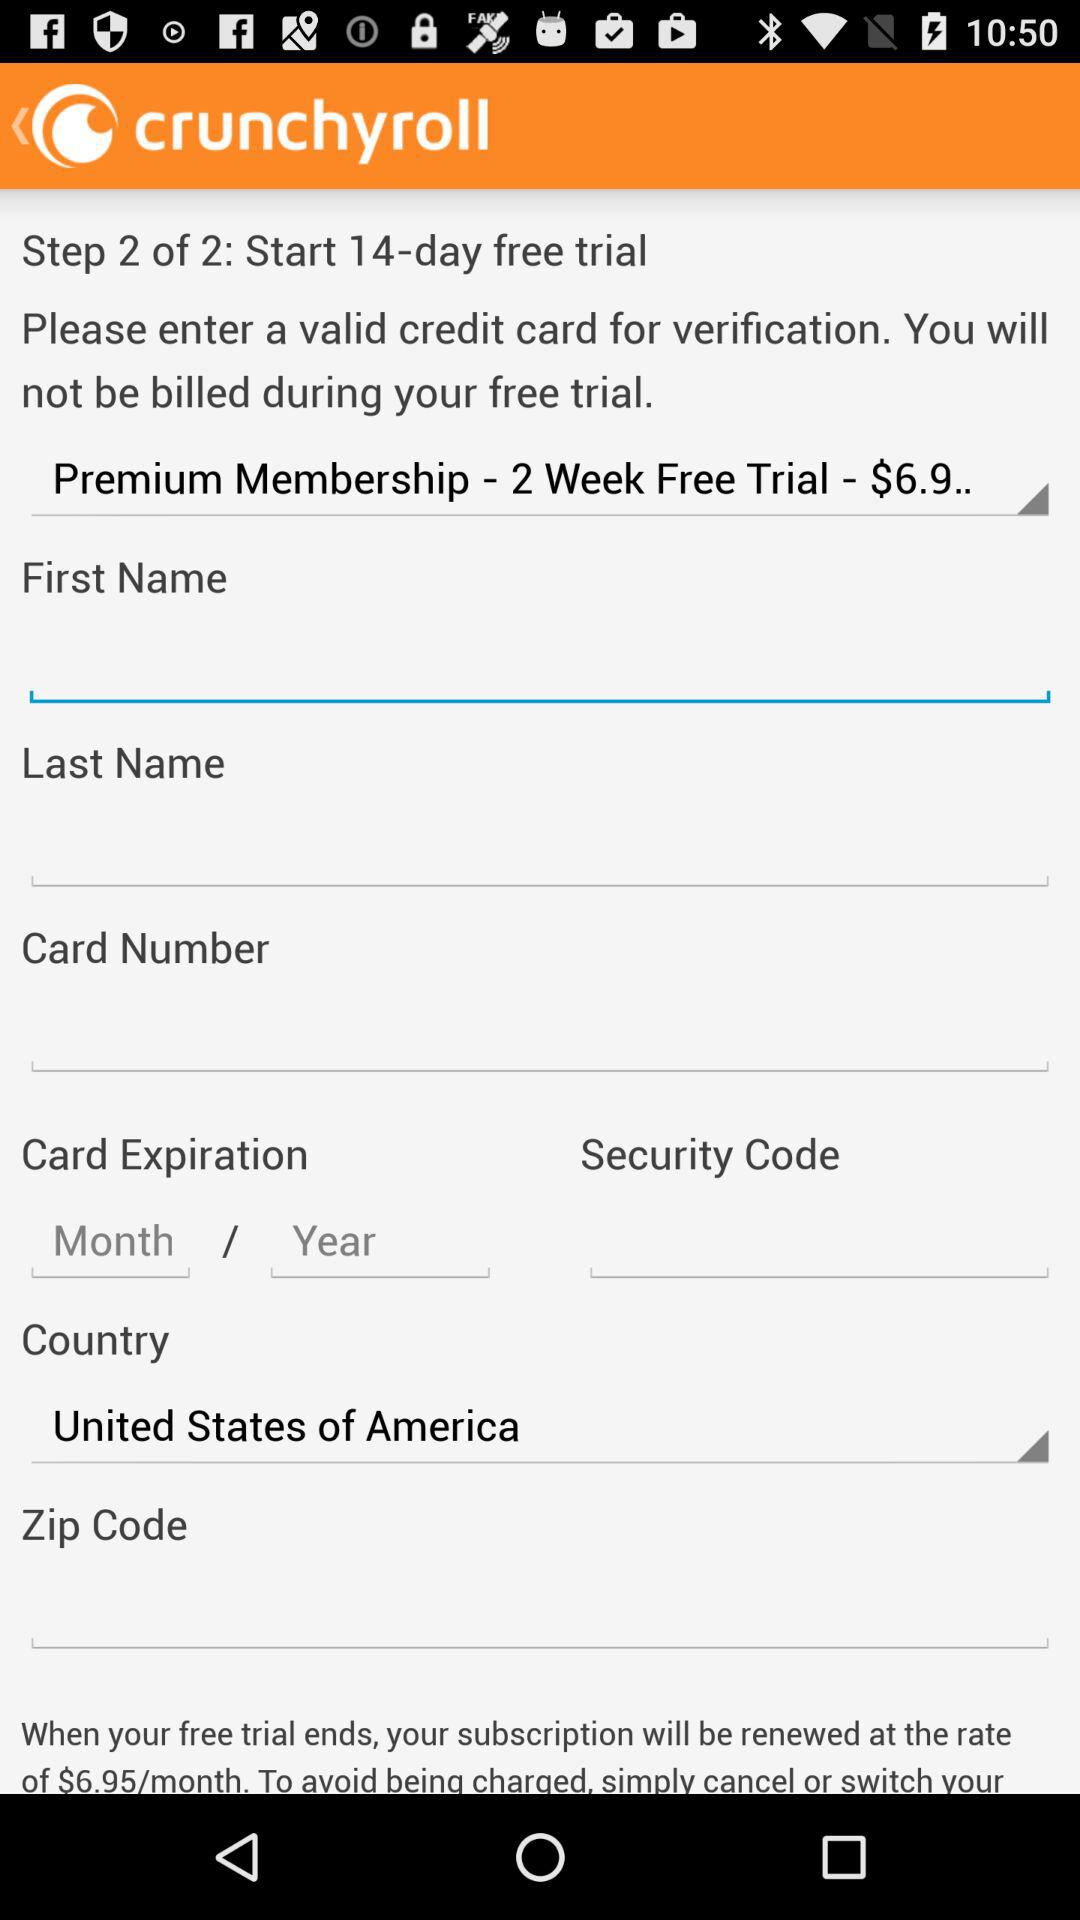What does the premium membership cost? The premium membership cost is $6.95/month. 